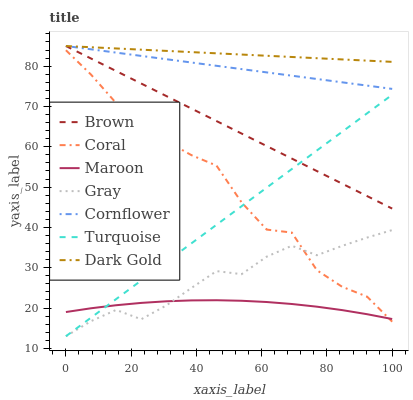Does Maroon have the minimum area under the curve?
Answer yes or no. Yes. Does Dark Gold have the maximum area under the curve?
Answer yes or no. Yes. Does Turquoise have the minimum area under the curve?
Answer yes or no. No. Does Turquoise have the maximum area under the curve?
Answer yes or no. No. Is Turquoise the smoothest?
Answer yes or no. Yes. Is Coral the roughest?
Answer yes or no. Yes. Is Cornflower the smoothest?
Answer yes or no. No. Is Cornflower the roughest?
Answer yes or no. No. Does Turquoise have the lowest value?
Answer yes or no. Yes. Does Cornflower have the lowest value?
Answer yes or no. No. Does Dark Gold have the highest value?
Answer yes or no. Yes. Does Turquoise have the highest value?
Answer yes or no. No. Is Turquoise less than Cornflower?
Answer yes or no. Yes. Is Brown greater than Coral?
Answer yes or no. Yes. Does Cornflower intersect Brown?
Answer yes or no. Yes. Is Cornflower less than Brown?
Answer yes or no. No. Is Cornflower greater than Brown?
Answer yes or no. No. Does Turquoise intersect Cornflower?
Answer yes or no. No. 